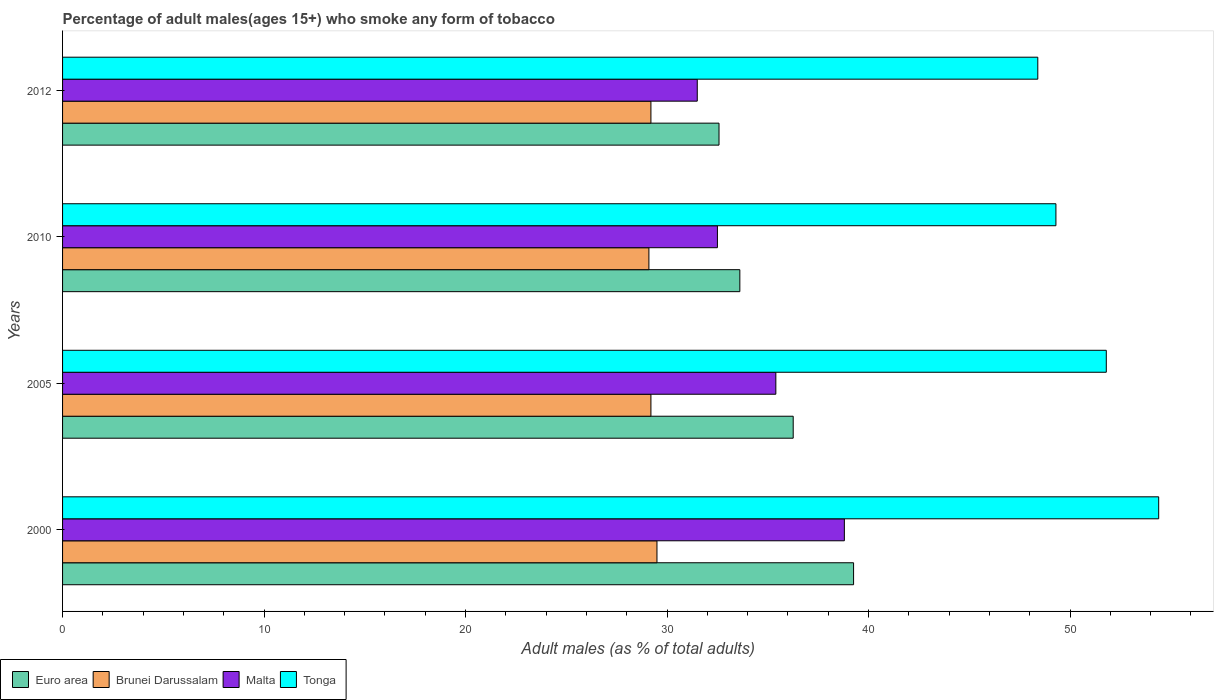How many different coloured bars are there?
Make the answer very short. 4. Are the number of bars per tick equal to the number of legend labels?
Your response must be concise. Yes. Are the number of bars on each tick of the Y-axis equal?
Make the answer very short. Yes. In how many cases, is the number of bars for a given year not equal to the number of legend labels?
Offer a terse response. 0. What is the percentage of adult males who smoke in Brunei Darussalam in 2010?
Offer a very short reply. 29.1. Across all years, what is the maximum percentage of adult males who smoke in Tonga?
Provide a succinct answer. 54.4. Across all years, what is the minimum percentage of adult males who smoke in Tonga?
Provide a succinct answer. 48.4. In which year was the percentage of adult males who smoke in Euro area maximum?
Make the answer very short. 2000. In which year was the percentage of adult males who smoke in Euro area minimum?
Keep it short and to the point. 2012. What is the total percentage of adult males who smoke in Euro area in the graph?
Your response must be concise. 141.71. What is the difference between the percentage of adult males who smoke in Malta in 2000 and that in 2010?
Offer a terse response. 6.3. What is the difference between the percentage of adult males who smoke in Brunei Darussalam in 2010 and the percentage of adult males who smoke in Tonga in 2005?
Give a very brief answer. -22.7. What is the average percentage of adult males who smoke in Euro area per year?
Ensure brevity in your answer.  35.43. In the year 2012, what is the difference between the percentage of adult males who smoke in Malta and percentage of adult males who smoke in Euro area?
Offer a very short reply. -1.08. What is the ratio of the percentage of adult males who smoke in Malta in 2000 to that in 2005?
Offer a very short reply. 1.1. What is the difference between the highest and the second highest percentage of adult males who smoke in Tonga?
Provide a succinct answer. 2.6. What is the difference between the highest and the lowest percentage of adult males who smoke in Malta?
Offer a terse response. 7.3. What does the 3rd bar from the top in 2012 represents?
Ensure brevity in your answer.  Brunei Darussalam. What does the 4th bar from the bottom in 2005 represents?
Provide a short and direct response. Tonga. Is it the case that in every year, the sum of the percentage of adult males who smoke in Malta and percentage of adult males who smoke in Brunei Darussalam is greater than the percentage of adult males who smoke in Euro area?
Your answer should be very brief. Yes. How many bars are there?
Offer a very short reply. 16. Are all the bars in the graph horizontal?
Give a very brief answer. Yes. How many years are there in the graph?
Offer a terse response. 4. What is the difference between two consecutive major ticks on the X-axis?
Ensure brevity in your answer.  10. Are the values on the major ticks of X-axis written in scientific E-notation?
Give a very brief answer. No. Does the graph contain grids?
Provide a short and direct response. No. Where does the legend appear in the graph?
Keep it short and to the point. Bottom left. How many legend labels are there?
Offer a very short reply. 4. How are the legend labels stacked?
Your answer should be very brief. Horizontal. What is the title of the graph?
Provide a short and direct response. Percentage of adult males(ages 15+) who smoke any form of tobacco. Does "Syrian Arab Republic" appear as one of the legend labels in the graph?
Provide a succinct answer. No. What is the label or title of the X-axis?
Give a very brief answer. Adult males (as % of total adults). What is the Adult males (as % of total adults) in Euro area in 2000?
Make the answer very short. 39.26. What is the Adult males (as % of total adults) of Brunei Darussalam in 2000?
Provide a succinct answer. 29.5. What is the Adult males (as % of total adults) of Malta in 2000?
Offer a terse response. 38.8. What is the Adult males (as % of total adults) of Tonga in 2000?
Provide a short and direct response. 54.4. What is the Adult males (as % of total adults) in Euro area in 2005?
Provide a succinct answer. 36.26. What is the Adult males (as % of total adults) of Brunei Darussalam in 2005?
Provide a short and direct response. 29.2. What is the Adult males (as % of total adults) of Malta in 2005?
Provide a short and direct response. 35.4. What is the Adult males (as % of total adults) of Tonga in 2005?
Your answer should be very brief. 51.8. What is the Adult males (as % of total adults) of Euro area in 2010?
Keep it short and to the point. 33.61. What is the Adult males (as % of total adults) in Brunei Darussalam in 2010?
Your answer should be very brief. 29.1. What is the Adult males (as % of total adults) in Malta in 2010?
Provide a succinct answer. 32.5. What is the Adult males (as % of total adults) of Tonga in 2010?
Your answer should be very brief. 49.3. What is the Adult males (as % of total adults) in Euro area in 2012?
Make the answer very short. 32.58. What is the Adult males (as % of total adults) of Brunei Darussalam in 2012?
Your answer should be compact. 29.2. What is the Adult males (as % of total adults) in Malta in 2012?
Provide a short and direct response. 31.5. What is the Adult males (as % of total adults) in Tonga in 2012?
Make the answer very short. 48.4. Across all years, what is the maximum Adult males (as % of total adults) in Euro area?
Give a very brief answer. 39.26. Across all years, what is the maximum Adult males (as % of total adults) in Brunei Darussalam?
Your answer should be very brief. 29.5. Across all years, what is the maximum Adult males (as % of total adults) in Malta?
Your answer should be very brief. 38.8. Across all years, what is the maximum Adult males (as % of total adults) of Tonga?
Ensure brevity in your answer.  54.4. Across all years, what is the minimum Adult males (as % of total adults) of Euro area?
Offer a very short reply. 32.58. Across all years, what is the minimum Adult males (as % of total adults) in Brunei Darussalam?
Give a very brief answer. 29.1. Across all years, what is the minimum Adult males (as % of total adults) in Malta?
Offer a terse response. 31.5. Across all years, what is the minimum Adult males (as % of total adults) in Tonga?
Provide a short and direct response. 48.4. What is the total Adult males (as % of total adults) in Euro area in the graph?
Provide a succinct answer. 141.71. What is the total Adult males (as % of total adults) of Brunei Darussalam in the graph?
Provide a short and direct response. 117. What is the total Adult males (as % of total adults) in Malta in the graph?
Your response must be concise. 138.2. What is the total Adult males (as % of total adults) in Tonga in the graph?
Your answer should be compact. 203.9. What is the difference between the Adult males (as % of total adults) of Euro area in 2000 and that in 2005?
Provide a succinct answer. 3. What is the difference between the Adult males (as % of total adults) of Brunei Darussalam in 2000 and that in 2005?
Your answer should be very brief. 0.3. What is the difference between the Adult males (as % of total adults) in Malta in 2000 and that in 2005?
Make the answer very short. 3.4. What is the difference between the Adult males (as % of total adults) of Euro area in 2000 and that in 2010?
Provide a short and direct response. 5.64. What is the difference between the Adult males (as % of total adults) in Tonga in 2000 and that in 2010?
Keep it short and to the point. 5.1. What is the difference between the Adult males (as % of total adults) of Euro area in 2000 and that in 2012?
Offer a very short reply. 6.68. What is the difference between the Adult males (as % of total adults) in Malta in 2000 and that in 2012?
Offer a very short reply. 7.3. What is the difference between the Adult males (as % of total adults) in Tonga in 2000 and that in 2012?
Make the answer very short. 6. What is the difference between the Adult males (as % of total adults) in Euro area in 2005 and that in 2010?
Give a very brief answer. 2.65. What is the difference between the Adult males (as % of total adults) in Brunei Darussalam in 2005 and that in 2010?
Your answer should be very brief. 0.1. What is the difference between the Adult males (as % of total adults) in Malta in 2005 and that in 2010?
Keep it short and to the point. 2.9. What is the difference between the Adult males (as % of total adults) in Tonga in 2005 and that in 2010?
Make the answer very short. 2.5. What is the difference between the Adult males (as % of total adults) of Euro area in 2005 and that in 2012?
Give a very brief answer. 3.68. What is the difference between the Adult males (as % of total adults) in Euro area in 2010 and that in 2012?
Your answer should be compact. 1.03. What is the difference between the Adult males (as % of total adults) of Malta in 2010 and that in 2012?
Your answer should be compact. 1. What is the difference between the Adult males (as % of total adults) of Euro area in 2000 and the Adult males (as % of total adults) of Brunei Darussalam in 2005?
Make the answer very short. 10.06. What is the difference between the Adult males (as % of total adults) of Euro area in 2000 and the Adult males (as % of total adults) of Malta in 2005?
Your response must be concise. 3.86. What is the difference between the Adult males (as % of total adults) of Euro area in 2000 and the Adult males (as % of total adults) of Tonga in 2005?
Your response must be concise. -12.54. What is the difference between the Adult males (as % of total adults) in Brunei Darussalam in 2000 and the Adult males (as % of total adults) in Tonga in 2005?
Offer a terse response. -22.3. What is the difference between the Adult males (as % of total adults) in Euro area in 2000 and the Adult males (as % of total adults) in Brunei Darussalam in 2010?
Ensure brevity in your answer.  10.16. What is the difference between the Adult males (as % of total adults) in Euro area in 2000 and the Adult males (as % of total adults) in Malta in 2010?
Your answer should be very brief. 6.76. What is the difference between the Adult males (as % of total adults) of Euro area in 2000 and the Adult males (as % of total adults) of Tonga in 2010?
Offer a very short reply. -10.04. What is the difference between the Adult males (as % of total adults) of Brunei Darussalam in 2000 and the Adult males (as % of total adults) of Tonga in 2010?
Your answer should be compact. -19.8. What is the difference between the Adult males (as % of total adults) of Euro area in 2000 and the Adult males (as % of total adults) of Brunei Darussalam in 2012?
Ensure brevity in your answer.  10.06. What is the difference between the Adult males (as % of total adults) of Euro area in 2000 and the Adult males (as % of total adults) of Malta in 2012?
Your response must be concise. 7.76. What is the difference between the Adult males (as % of total adults) of Euro area in 2000 and the Adult males (as % of total adults) of Tonga in 2012?
Provide a short and direct response. -9.14. What is the difference between the Adult males (as % of total adults) in Brunei Darussalam in 2000 and the Adult males (as % of total adults) in Tonga in 2012?
Your answer should be very brief. -18.9. What is the difference between the Adult males (as % of total adults) in Euro area in 2005 and the Adult males (as % of total adults) in Brunei Darussalam in 2010?
Give a very brief answer. 7.16. What is the difference between the Adult males (as % of total adults) in Euro area in 2005 and the Adult males (as % of total adults) in Malta in 2010?
Give a very brief answer. 3.76. What is the difference between the Adult males (as % of total adults) in Euro area in 2005 and the Adult males (as % of total adults) in Tonga in 2010?
Ensure brevity in your answer.  -13.04. What is the difference between the Adult males (as % of total adults) of Brunei Darussalam in 2005 and the Adult males (as % of total adults) of Tonga in 2010?
Offer a terse response. -20.1. What is the difference between the Adult males (as % of total adults) of Malta in 2005 and the Adult males (as % of total adults) of Tonga in 2010?
Provide a succinct answer. -13.9. What is the difference between the Adult males (as % of total adults) of Euro area in 2005 and the Adult males (as % of total adults) of Brunei Darussalam in 2012?
Keep it short and to the point. 7.06. What is the difference between the Adult males (as % of total adults) of Euro area in 2005 and the Adult males (as % of total adults) of Malta in 2012?
Your answer should be very brief. 4.76. What is the difference between the Adult males (as % of total adults) in Euro area in 2005 and the Adult males (as % of total adults) in Tonga in 2012?
Ensure brevity in your answer.  -12.14. What is the difference between the Adult males (as % of total adults) of Brunei Darussalam in 2005 and the Adult males (as % of total adults) of Tonga in 2012?
Provide a short and direct response. -19.2. What is the difference between the Adult males (as % of total adults) of Euro area in 2010 and the Adult males (as % of total adults) of Brunei Darussalam in 2012?
Make the answer very short. 4.41. What is the difference between the Adult males (as % of total adults) of Euro area in 2010 and the Adult males (as % of total adults) of Malta in 2012?
Your response must be concise. 2.11. What is the difference between the Adult males (as % of total adults) in Euro area in 2010 and the Adult males (as % of total adults) in Tonga in 2012?
Offer a very short reply. -14.79. What is the difference between the Adult males (as % of total adults) of Brunei Darussalam in 2010 and the Adult males (as % of total adults) of Tonga in 2012?
Make the answer very short. -19.3. What is the difference between the Adult males (as % of total adults) of Malta in 2010 and the Adult males (as % of total adults) of Tonga in 2012?
Give a very brief answer. -15.9. What is the average Adult males (as % of total adults) in Euro area per year?
Provide a short and direct response. 35.43. What is the average Adult males (as % of total adults) of Brunei Darussalam per year?
Your response must be concise. 29.25. What is the average Adult males (as % of total adults) in Malta per year?
Make the answer very short. 34.55. What is the average Adult males (as % of total adults) of Tonga per year?
Your answer should be compact. 50.98. In the year 2000, what is the difference between the Adult males (as % of total adults) in Euro area and Adult males (as % of total adults) in Brunei Darussalam?
Provide a short and direct response. 9.76. In the year 2000, what is the difference between the Adult males (as % of total adults) in Euro area and Adult males (as % of total adults) in Malta?
Provide a succinct answer. 0.46. In the year 2000, what is the difference between the Adult males (as % of total adults) of Euro area and Adult males (as % of total adults) of Tonga?
Ensure brevity in your answer.  -15.14. In the year 2000, what is the difference between the Adult males (as % of total adults) in Brunei Darussalam and Adult males (as % of total adults) in Malta?
Give a very brief answer. -9.3. In the year 2000, what is the difference between the Adult males (as % of total adults) in Brunei Darussalam and Adult males (as % of total adults) in Tonga?
Make the answer very short. -24.9. In the year 2000, what is the difference between the Adult males (as % of total adults) of Malta and Adult males (as % of total adults) of Tonga?
Your answer should be compact. -15.6. In the year 2005, what is the difference between the Adult males (as % of total adults) in Euro area and Adult males (as % of total adults) in Brunei Darussalam?
Provide a succinct answer. 7.06. In the year 2005, what is the difference between the Adult males (as % of total adults) in Euro area and Adult males (as % of total adults) in Malta?
Ensure brevity in your answer.  0.86. In the year 2005, what is the difference between the Adult males (as % of total adults) in Euro area and Adult males (as % of total adults) in Tonga?
Your answer should be very brief. -15.54. In the year 2005, what is the difference between the Adult males (as % of total adults) in Brunei Darussalam and Adult males (as % of total adults) in Tonga?
Give a very brief answer. -22.6. In the year 2005, what is the difference between the Adult males (as % of total adults) of Malta and Adult males (as % of total adults) of Tonga?
Provide a short and direct response. -16.4. In the year 2010, what is the difference between the Adult males (as % of total adults) in Euro area and Adult males (as % of total adults) in Brunei Darussalam?
Provide a succinct answer. 4.51. In the year 2010, what is the difference between the Adult males (as % of total adults) in Euro area and Adult males (as % of total adults) in Malta?
Your response must be concise. 1.11. In the year 2010, what is the difference between the Adult males (as % of total adults) of Euro area and Adult males (as % of total adults) of Tonga?
Your answer should be very brief. -15.69. In the year 2010, what is the difference between the Adult males (as % of total adults) of Brunei Darussalam and Adult males (as % of total adults) of Tonga?
Provide a succinct answer. -20.2. In the year 2010, what is the difference between the Adult males (as % of total adults) in Malta and Adult males (as % of total adults) in Tonga?
Ensure brevity in your answer.  -16.8. In the year 2012, what is the difference between the Adult males (as % of total adults) of Euro area and Adult males (as % of total adults) of Brunei Darussalam?
Your response must be concise. 3.38. In the year 2012, what is the difference between the Adult males (as % of total adults) in Euro area and Adult males (as % of total adults) in Malta?
Offer a terse response. 1.08. In the year 2012, what is the difference between the Adult males (as % of total adults) of Euro area and Adult males (as % of total adults) of Tonga?
Your answer should be compact. -15.82. In the year 2012, what is the difference between the Adult males (as % of total adults) in Brunei Darussalam and Adult males (as % of total adults) in Tonga?
Keep it short and to the point. -19.2. In the year 2012, what is the difference between the Adult males (as % of total adults) in Malta and Adult males (as % of total adults) in Tonga?
Provide a succinct answer. -16.9. What is the ratio of the Adult males (as % of total adults) of Euro area in 2000 to that in 2005?
Give a very brief answer. 1.08. What is the ratio of the Adult males (as % of total adults) of Brunei Darussalam in 2000 to that in 2005?
Your answer should be very brief. 1.01. What is the ratio of the Adult males (as % of total adults) of Malta in 2000 to that in 2005?
Offer a very short reply. 1.1. What is the ratio of the Adult males (as % of total adults) in Tonga in 2000 to that in 2005?
Your answer should be very brief. 1.05. What is the ratio of the Adult males (as % of total adults) in Euro area in 2000 to that in 2010?
Your answer should be very brief. 1.17. What is the ratio of the Adult males (as % of total adults) of Brunei Darussalam in 2000 to that in 2010?
Ensure brevity in your answer.  1.01. What is the ratio of the Adult males (as % of total adults) in Malta in 2000 to that in 2010?
Ensure brevity in your answer.  1.19. What is the ratio of the Adult males (as % of total adults) of Tonga in 2000 to that in 2010?
Your response must be concise. 1.1. What is the ratio of the Adult males (as % of total adults) of Euro area in 2000 to that in 2012?
Offer a terse response. 1.21. What is the ratio of the Adult males (as % of total adults) of Brunei Darussalam in 2000 to that in 2012?
Your answer should be very brief. 1.01. What is the ratio of the Adult males (as % of total adults) in Malta in 2000 to that in 2012?
Make the answer very short. 1.23. What is the ratio of the Adult males (as % of total adults) in Tonga in 2000 to that in 2012?
Ensure brevity in your answer.  1.12. What is the ratio of the Adult males (as % of total adults) of Euro area in 2005 to that in 2010?
Ensure brevity in your answer.  1.08. What is the ratio of the Adult males (as % of total adults) of Malta in 2005 to that in 2010?
Keep it short and to the point. 1.09. What is the ratio of the Adult males (as % of total adults) in Tonga in 2005 to that in 2010?
Your answer should be compact. 1.05. What is the ratio of the Adult males (as % of total adults) of Euro area in 2005 to that in 2012?
Provide a short and direct response. 1.11. What is the ratio of the Adult males (as % of total adults) of Malta in 2005 to that in 2012?
Provide a short and direct response. 1.12. What is the ratio of the Adult males (as % of total adults) of Tonga in 2005 to that in 2012?
Give a very brief answer. 1.07. What is the ratio of the Adult males (as % of total adults) of Euro area in 2010 to that in 2012?
Provide a succinct answer. 1.03. What is the ratio of the Adult males (as % of total adults) in Brunei Darussalam in 2010 to that in 2012?
Offer a terse response. 1. What is the ratio of the Adult males (as % of total adults) of Malta in 2010 to that in 2012?
Give a very brief answer. 1.03. What is the ratio of the Adult males (as % of total adults) in Tonga in 2010 to that in 2012?
Your response must be concise. 1.02. What is the difference between the highest and the second highest Adult males (as % of total adults) in Euro area?
Your answer should be very brief. 3. What is the difference between the highest and the second highest Adult males (as % of total adults) of Malta?
Offer a terse response. 3.4. What is the difference between the highest and the second highest Adult males (as % of total adults) of Tonga?
Ensure brevity in your answer.  2.6. What is the difference between the highest and the lowest Adult males (as % of total adults) of Euro area?
Your response must be concise. 6.68. What is the difference between the highest and the lowest Adult males (as % of total adults) in Malta?
Your answer should be very brief. 7.3. 